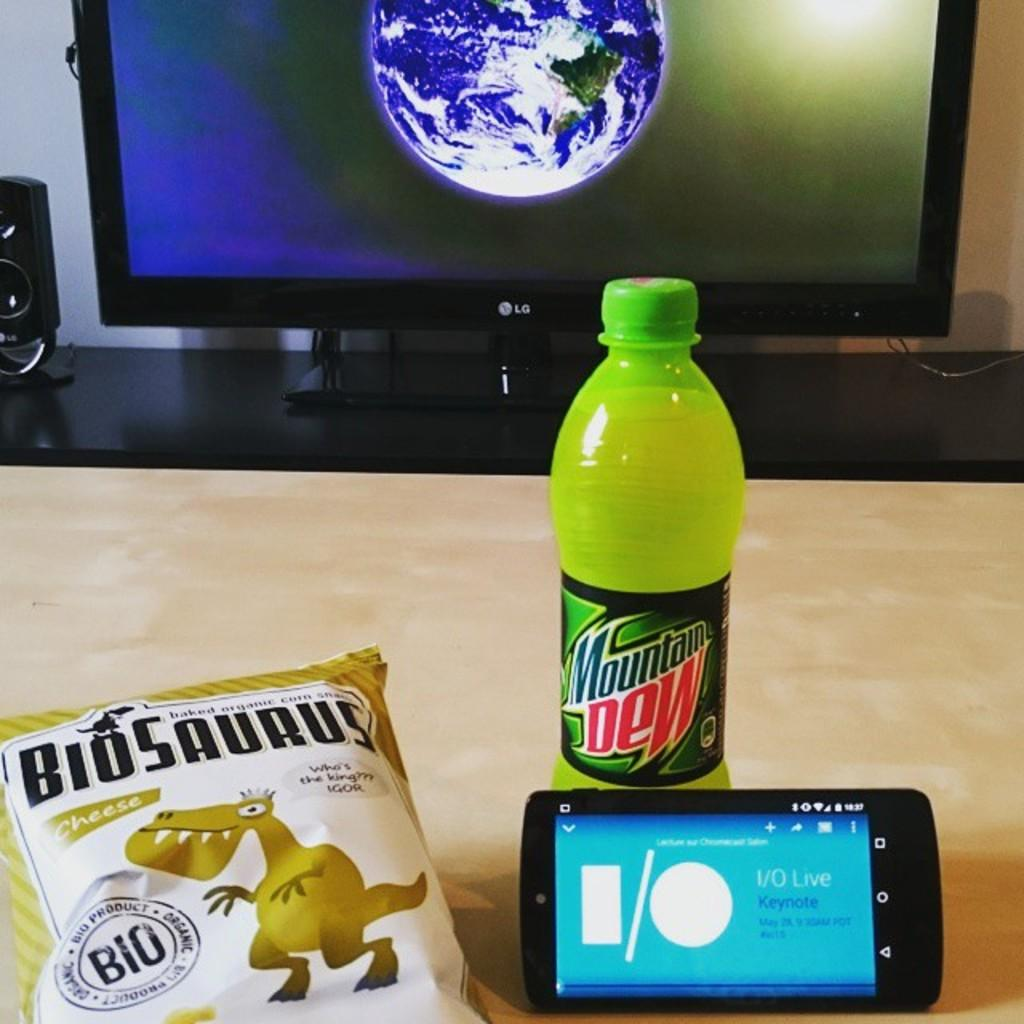<image>
Present a compact description of the photo's key features. An LG screen shows an image of Earth in front of a bag of "Biosaurus" chips, a Mountain Dew, and a smartphone. 